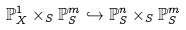<formula> <loc_0><loc_0><loc_500><loc_500>\mathbb { P } _ { X } ^ { 1 } \times _ { S } \mathbb { P } _ { S } ^ { m } \hookrightarrow \mathbb { P } _ { S } ^ { n } \times _ { S } \mathbb { P } _ { S } ^ { m }</formula> 